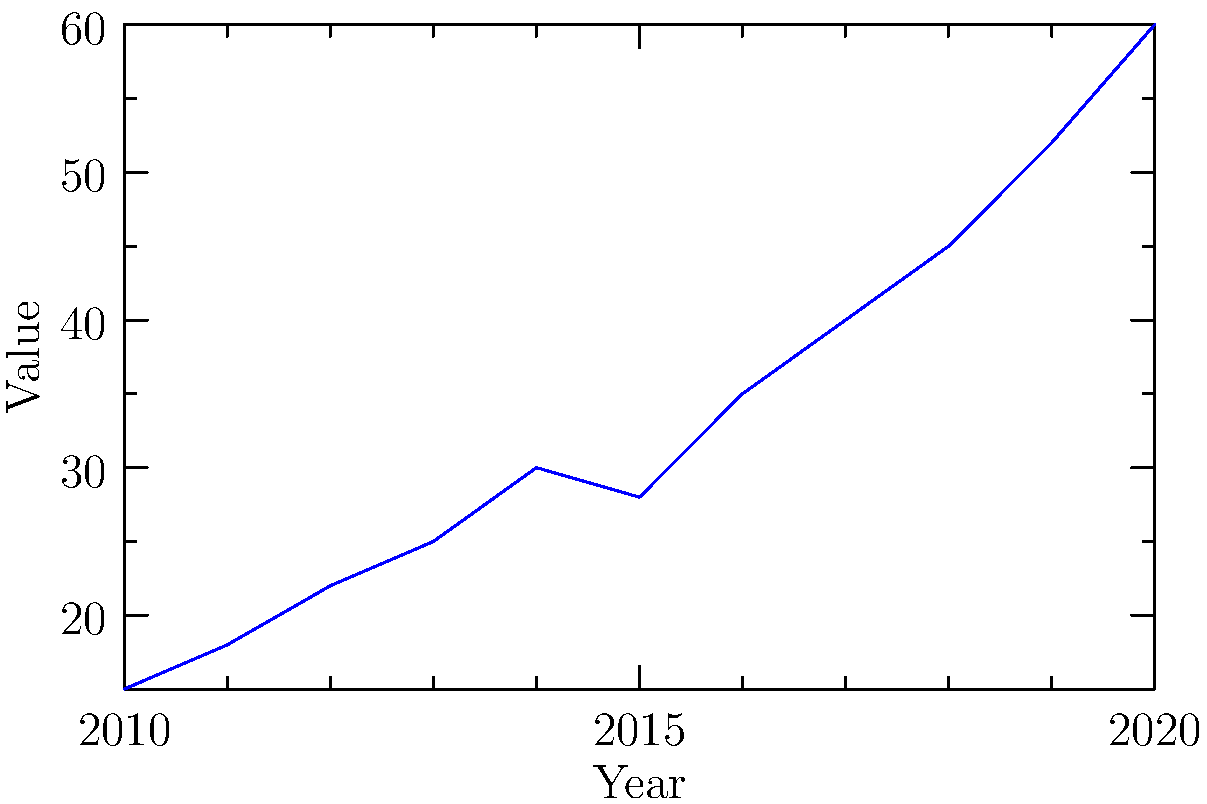Analyze the time series line graph displaying data from 2010 to 2020. Which of the following best describes the overall trend in the data?
A) Linear increase
B) Exponential growth
C) Cyclical pattern
D) Plateau To identify the trend in this time series line graph, we need to analyze the data points and their progression over time:

1. Observe the general direction: The line is moving upward from left to right, indicating an overall increasing trend.

2. Examine the rate of change:
   - From 2010 to 2014: The increase is relatively steady.
   - 2014 to 2015: There's a slight dip, but it doesn't change the overall trend.
   - 2015 to 2020: The increase becomes steeper.

3. Compare beginning and end points:
   - 2010: Value is around 15
   - 2020: Value is 60, which is a 4-fold increase over 10 years.

4. Assess the shape of the curve:
   - The line is not perfectly straight, which rules out a purely linear increase.
   - The steepening of the curve in later years suggests an accelerating growth rate.

5. Evaluate the options:
   A) Linear increase: While there is an increase, it's not consistent enough to be linear.
   B) Exponential growth: This best fits the observed pattern, with accelerating growth over time.
   C) Cyclical pattern: There's no repetitive up-and-down pattern.
   D) Plateau: The data doesn't level off; it continues to increase.

Given the accelerating growth rate and the overall shape of the curve, the best description of the trend is exponential growth.
Answer: B) Exponential growth 